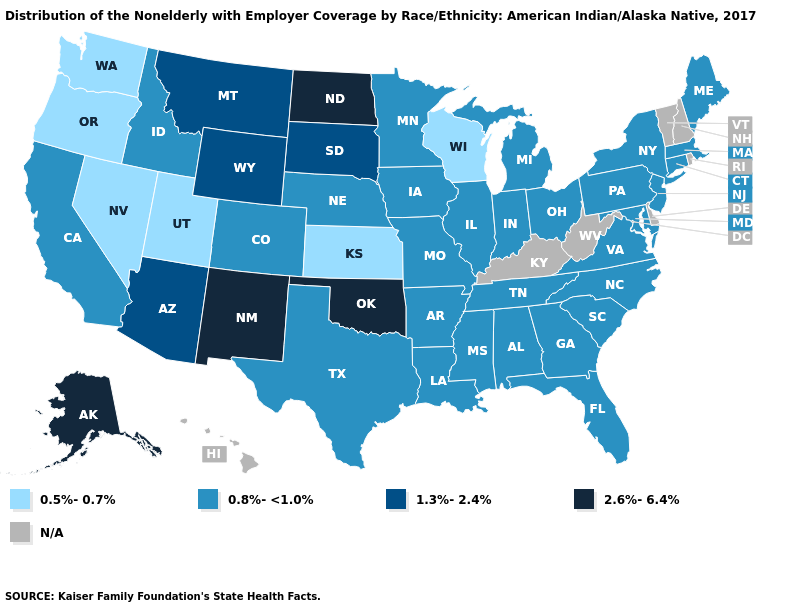Does Arizona have the lowest value in the USA?
Keep it brief. No. Name the states that have a value in the range 0.5%-0.7%?
Give a very brief answer. Kansas, Nevada, Oregon, Utah, Washington, Wisconsin. Name the states that have a value in the range 1.3%-2.4%?
Be succinct. Arizona, Montana, South Dakota, Wyoming. What is the highest value in states that border Kentucky?
Keep it brief. 0.8%-<1.0%. What is the value of Texas?
Quick response, please. 0.8%-<1.0%. Does Oklahoma have the lowest value in the South?
Short answer required. No. Which states have the lowest value in the USA?
Concise answer only. Kansas, Nevada, Oregon, Utah, Washington, Wisconsin. What is the value of Florida?
Answer briefly. 0.8%-<1.0%. Name the states that have a value in the range 1.3%-2.4%?
Answer briefly. Arizona, Montana, South Dakota, Wyoming. Among the states that border Connecticut , which have the lowest value?
Write a very short answer. Massachusetts, New York. Which states have the lowest value in the USA?
Write a very short answer. Kansas, Nevada, Oregon, Utah, Washington, Wisconsin. Which states hav the highest value in the Northeast?
Be succinct. Connecticut, Maine, Massachusetts, New Jersey, New York, Pennsylvania. What is the value of Illinois?
Concise answer only. 0.8%-<1.0%. Does the map have missing data?
Keep it brief. Yes. 